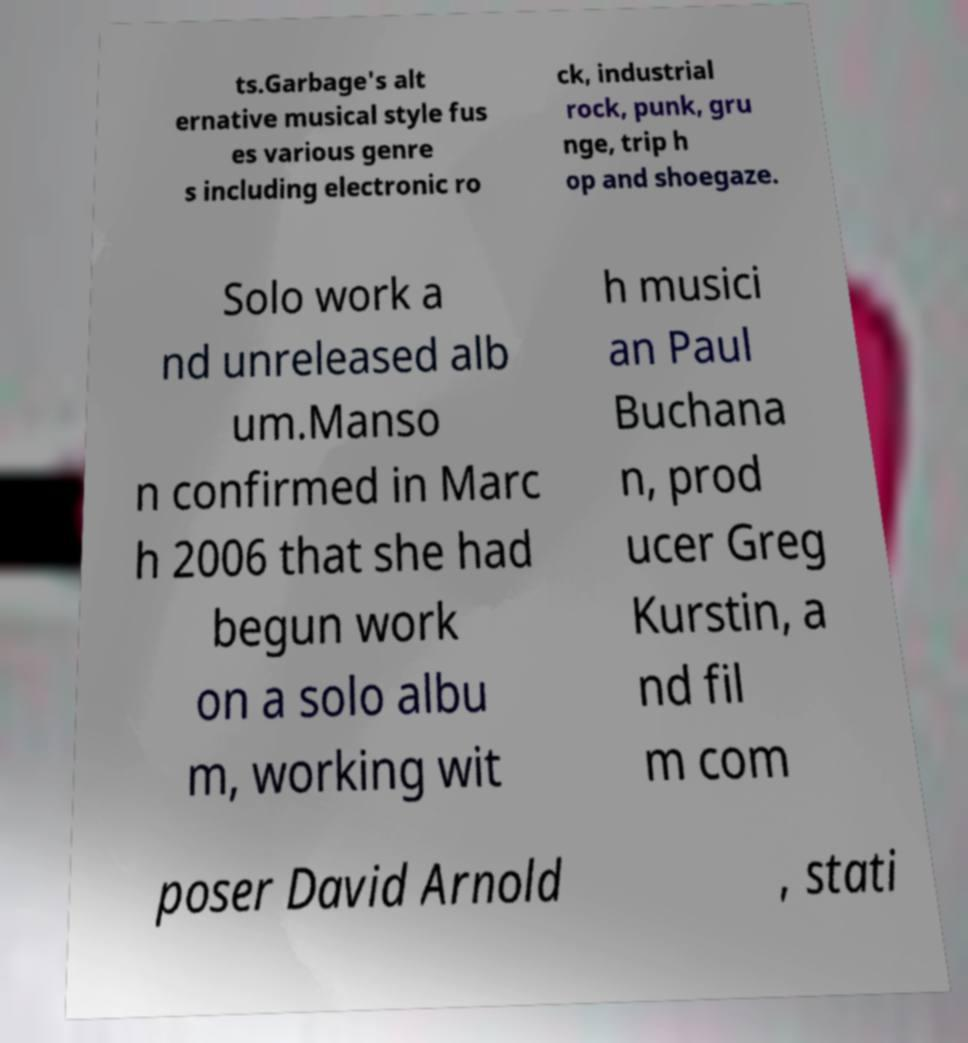Can you accurately transcribe the text from the provided image for me? ts.Garbage's alt ernative musical style fus es various genre s including electronic ro ck, industrial rock, punk, gru nge, trip h op and shoegaze. Solo work a nd unreleased alb um.Manso n confirmed in Marc h 2006 that she had begun work on a solo albu m, working wit h musici an Paul Buchana n, prod ucer Greg Kurstin, a nd fil m com poser David Arnold , stati 